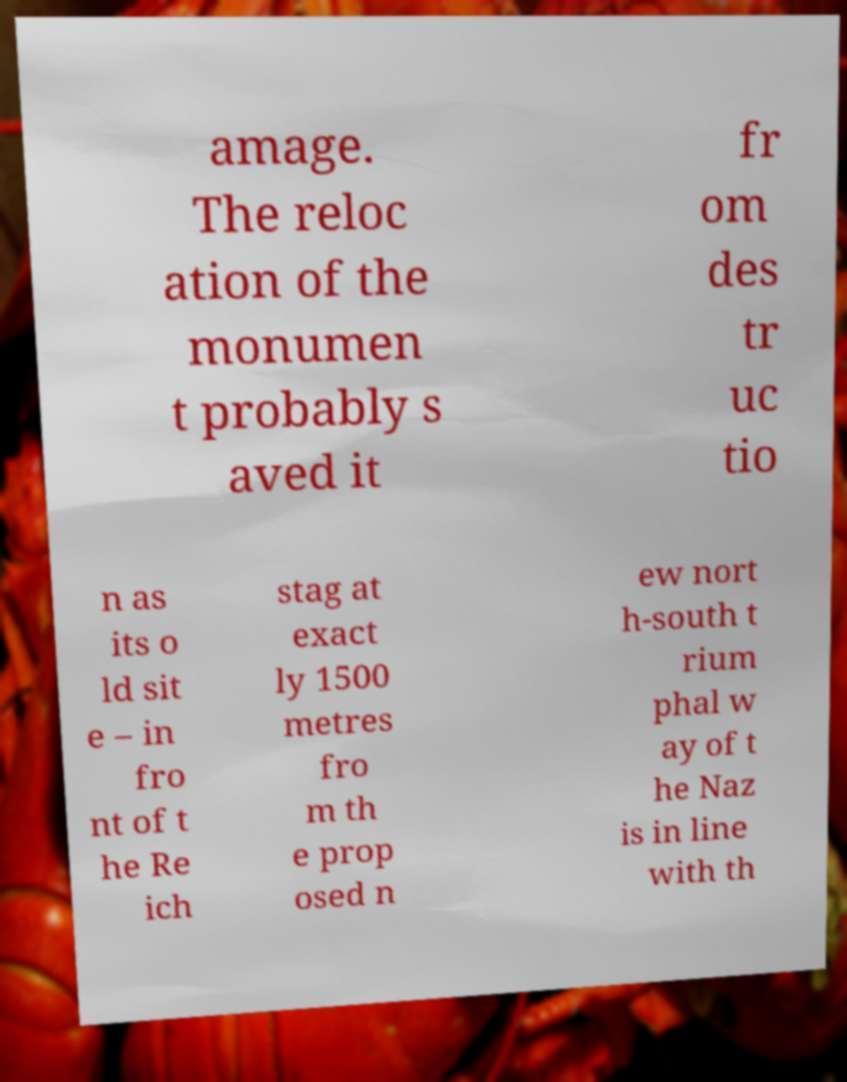Can you read and provide the text displayed in the image?This photo seems to have some interesting text. Can you extract and type it out for me? amage. The reloc ation of the monumen t probably s aved it fr om des tr uc tio n as its o ld sit e – in fro nt of t he Re ich stag at exact ly 1500 metres fro m th e prop osed n ew nort h-south t rium phal w ay of t he Naz is in line with th 